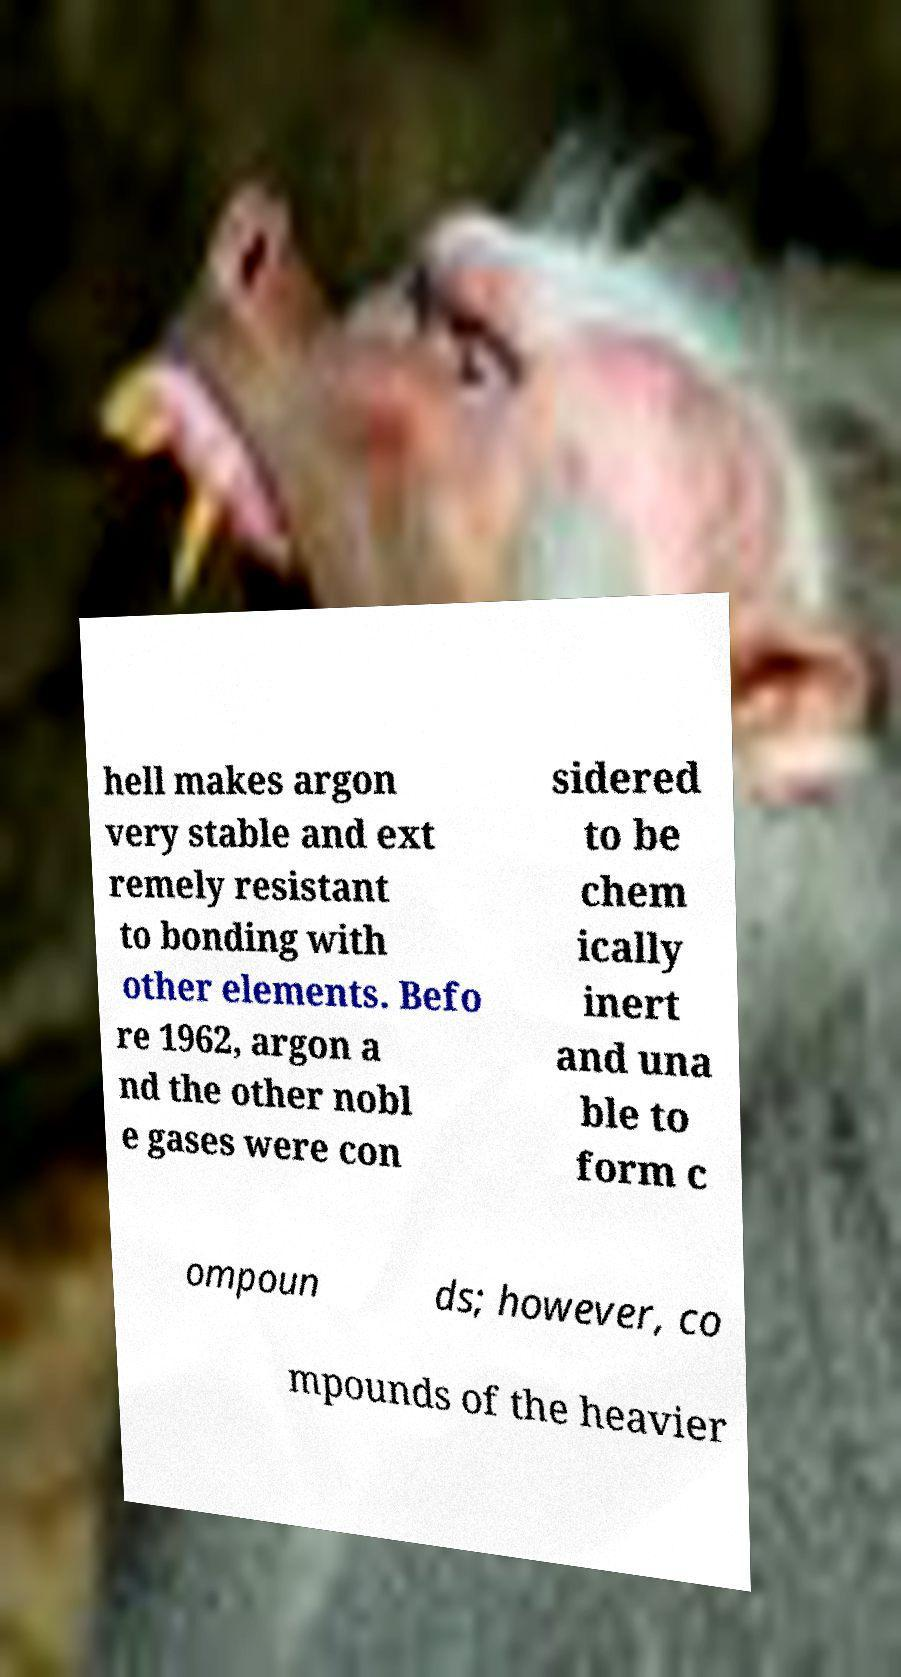What messages or text are displayed in this image? I need them in a readable, typed format. hell makes argon very stable and ext remely resistant to bonding with other elements. Befo re 1962, argon a nd the other nobl e gases were con sidered to be chem ically inert and una ble to form c ompoun ds; however, co mpounds of the heavier 